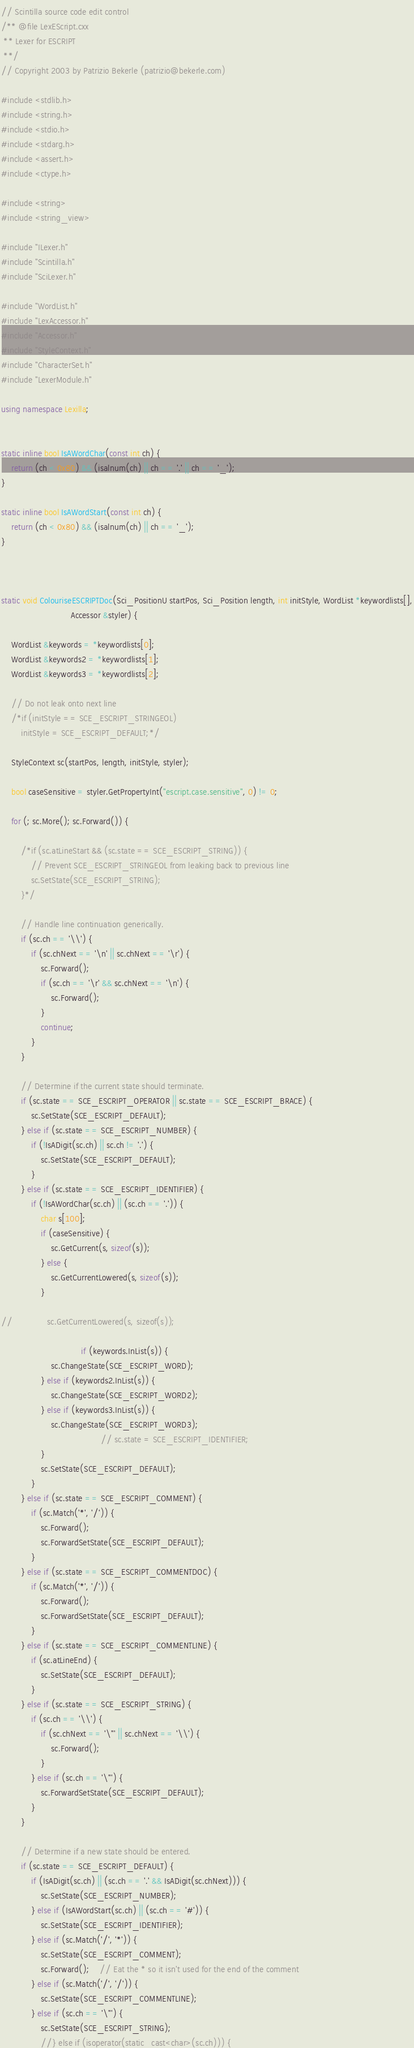Convert code to text. <code><loc_0><loc_0><loc_500><loc_500><_C++_>// Scintilla source code edit control
/** @file LexEScript.cxx
 ** Lexer for ESCRIPT
 **/
// Copyright 2003 by Patrizio Bekerle (patrizio@bekerle.com)

#include <stdlib.h>
#include <string.h>
#include <stdio.h>
#include <stdarg.h>
#include <assert.h>
#include <ctype.h>

#include <string>
#include <string_view>

#include "ILexer.h"
#include "Scintilla.h"
#include "SciLexer.h"

#include "WordList.h"
#include "LexAccessor.h"
#include "Accessor.h"
#include "StyleContext.h"
#include "CharacterSet.h"
#include "LexerModule.h"

using namespace Lexilla;


static inline bool IsAWordChar(const int ch) {
	return (ch < 0x80) && (isalnum(ch) || ch == '.' || ch == '_');
}

static inline bool IsAWordStart(const int ch) {
	return (ch < 0x80) && (isalnum(ch) || ch == '_');
}



static void ColouriseESCRIPTDoc(Sci_PositionU startPos, Sci_Position length, int initStyle, WordList *keywordlists[],
                            Accessor &styler) {

	WordList &keywords = *keywordlists[0];
	WordList &keywords2 = *keywordlists[1];
	WordList &keywords3 = *keywordlists[2];

	// Do not leak onto next line
	/*if (initStyle == SCE_ESCRIPT_STRINGEOL)
		initStyle = SCE_ESCRIPT_DEFAULT;*/

	StyleContext sc(startPos, length, initStyle, styler);

	bool caseSensitive = styler.GetPropertyInt("escript.case.sensitive", 0) != 0;

	for (; sc.More(); sc.Forward()) {

		/*if (sc.atLineStart && (sc.state == SCE_ESCRIPT_STRING)) {
			// Prevent SCE_ESCRIPT_STRINGEOL from leaking back to previous line
			sc.SetState(SCE_ESCRIPT_STRING);
		}*/

		// Handle line continuation generically.
		if (sc.ch == '\\') {
			if (sc.chNext == '\n' || sc.chNext == '\r') {
				sc.Forward();
				if (sc.ch == '\r' && sc.chNext == '\n') {
					sc.Forward();
				}
				continue;
			}
		}

		// Determine if the current state should terminate.
		if (sc.state == SCE_ESCRIPT_OPERATOR || sc.state == SCE_ESCRIPT_BRACE) {
			sc.SetState(SCE_ESCRIPT_DEFAULT);
		} else if (sc.state == SCE_ESCRIPT_NUMBER) {
			if (!IsADigit(sc.ch) || sc.ch != '.') {
				sc.SetState(SCE_ESCRIPT_DEFAULT);
			}
		} else if (sc.state == SCE_ESCRIPT_IDENTIFIER) {
			if (!IsAWordChar(sc.ch) || (sc.ch == '.')) {
				char s[100];
				if (caseSensitive) {
					sc.GetCurrent(s, sizeof(s));
				} else {
					sc.GetCurrentLowered(s, sizeof(s));
				}

//				sc.GetCurrentLowered(s, sizeof(s));

                                if (keywords.InList(s)) {
					sc.ChangeState(SCE_ESCRIPT_WORD);
				} else if (keywords2.InList(s)) {
					sc.ChangeState(SCE_ESCRIPT_WORD2);
				} else if (keywords3.InList(s)) {
					sc.ChangeState(SCE_ESCRIPT_WORD3);
                                        // sc.state = SCE_ESCRIPT_IDENTIFIER;
				}
				sc.SetState(SCE_ESCRIPT_DEFAULT);
			}
		} else if (sc.state == SCE_ESCRIPT_COMMENT) {
			if (sc.Match('*', '/')) {
				sc.Forward();
				sc.ForwardSetState(SCE_ESCRIPT_DEFAULT);
			}
		} else if (sc.state == SCE_ESCRIPT_COMMENTDOC) {
			if (sc.Match('*', '/')) {
				sc.Forward();
				sc.ForwardSetState(SCE_ESCRIPT_DEFAULT);
			}
		} else if (sc.state == SCE_ESCRIPT_COMMENTLINE) {
			if (sc.atLineEnd) {
				sc.SetState(SCE_ESCRIPT_DEFAULT);
			}
		} else if (sc.state == SCE_ESCRIPT_STRING) {
			if (sc.ch == '\\') {
				if (sc.chNext == '\"' || sc.chNext == '\\') {
					sc.Forward();
				}
			} else if (sc.ch == '\"') {
				sc.ForwardSetState(SCE_ESCRIPT_DEFAULT);
			}
		}

		// Determine if a new state should be entered.
		if (sc.state == SCE_ESCRIPT_DEFAULT) {
			if (IsADigit(sc.ch) || (sc.ch == '.' && IsADigit(sc.chNext))) {
				sc.SetState(SCE_ESCRIPT_NUMBER);
			} else if (IsAWordStart(sc.ch) || (sc.ch == '#')) {
				sc.SetState(SCE_ESCRIPT_IDENTIFIER);
			} else if (sc.Match('/', '*')) {
				sc.SetState(SCE_ESCRIPT_COMMENT);
				sc.Forward();	// Eat the * so it isn't used for the end of the comment
			} else if (sc.Match('/', '/')) {
				sc.SetState(SCE_ESCRIPT_COMMENTLINE);
			} else if (sc.ch == '\"') {
				sc.SetState(SCE_ESCRIPT_STRING);
				//} else if (isoperator(static_cast<char>(sc.ch))) {</code> 